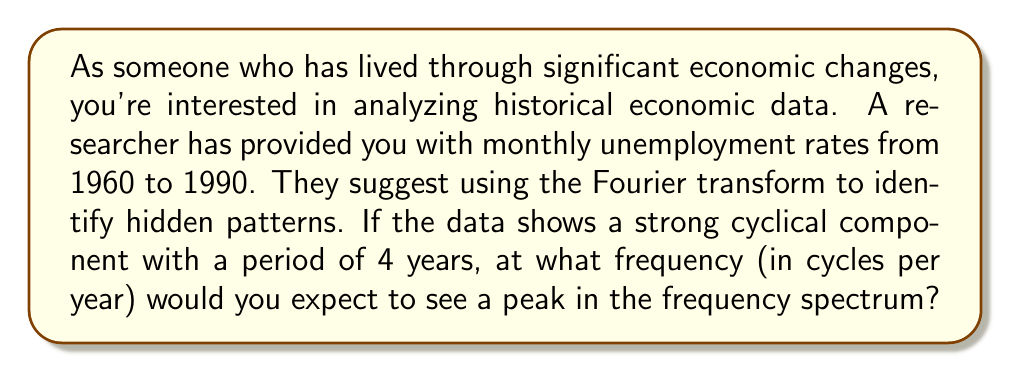Can you answer this question? To solve this problem, let's break it down into steps:

1) The Fourier transform helps us identify periodic components in time-series data by converting it from the time domain to the frequency domain.

2) We're told there's a cyclical component with a period of 4 years. Let's recall the relationship between period and frequency:

   $$ f = \frac{1}{T} $$

   Where $f$ is frequency and $T$ is period.

3) In this case:
   $$ T = 4 \text{ years} $$

4) Substituting into our equation:

   $$ f = \frac{1}{4} \text{ cycles per year} $$

5) This means we would expect to see a peak at 0.25 cycles per year in the frequency spectrum.

6) In the context of spectral analysis, this peak would represent a significant cyclical pattern in unemployment rates that repeats every 4 years. This could correspond to political cycles (as presidential terms are 4 years) or other economic cycles.

7) It's worth noting that in a real-world scenario, we might see additional peaks at multiples of this frequency (0.5, 0.75, 1 cycles/year, etc.) due to harmonics.
Answer: $0.25 \text{ cycles per year}$ 